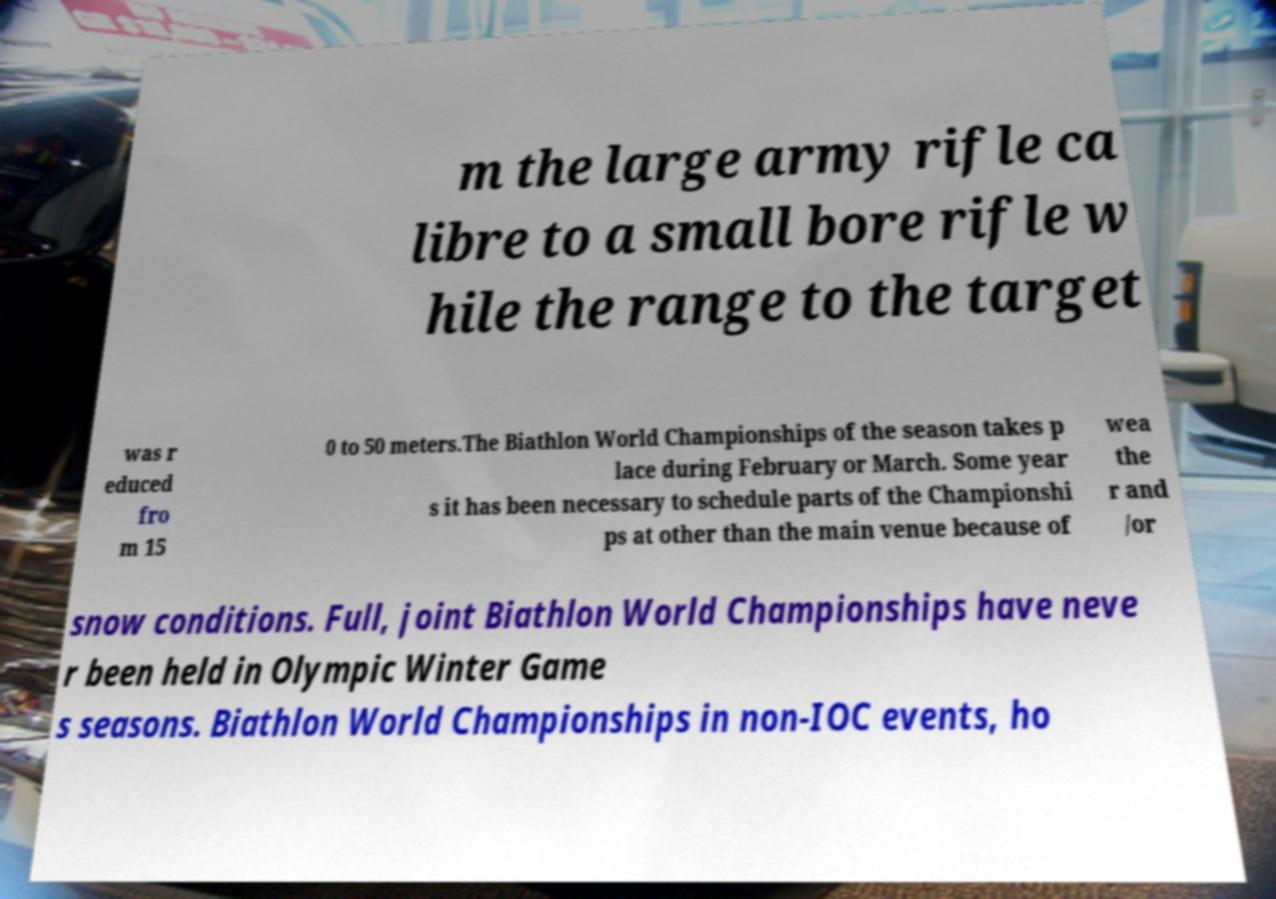Can you read and provide the text displayed in the image?This photo seems to have some interesting text. Can you extract and type it out for me? m the large army rifle ca libre to a small bore rifle w hile the range to the target was r educed fro m 15 0 to 50 meters.The Biathlon World Championships of the season takes p lace during February or March. Some year s it has been necessary to schedule parts of the Championshi ps at other than the main venue because of wea the r and /or snow conditions. Full, joint Biathlon World Championships have neve r been held in Olympic Winter Game s seasons. Biathlon World Championships in non-IOC events, ho 